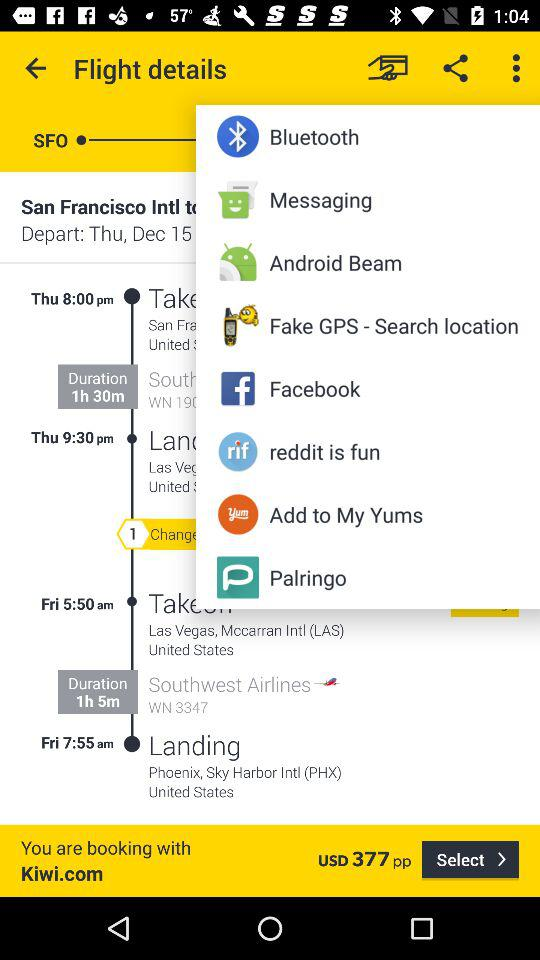What is the price of a flight ticket? The price of a flight ticket is 377 USD. 